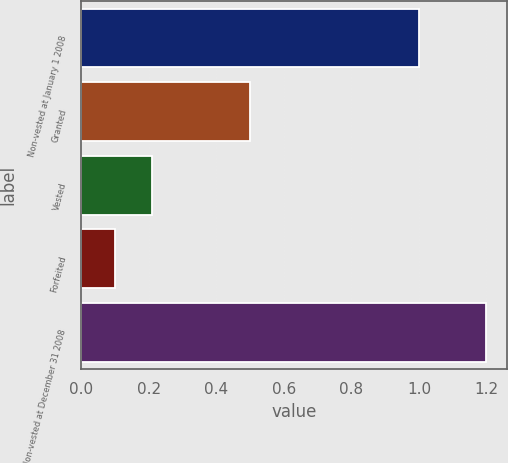Convert chart to OTSL. <chart><loc_0><loc_0><loc_500><loc_500><bar_chart><fcel>Non-vested at January 1 2008<fcel>Granted<fcel>Vested<fcel>Forfeited<fcel>Non-vested at December 31 2008<nl><fcel>1<fcel>0.5<fcel>0.21<fcel>0.1<fcel>1.2<nl></chart> 